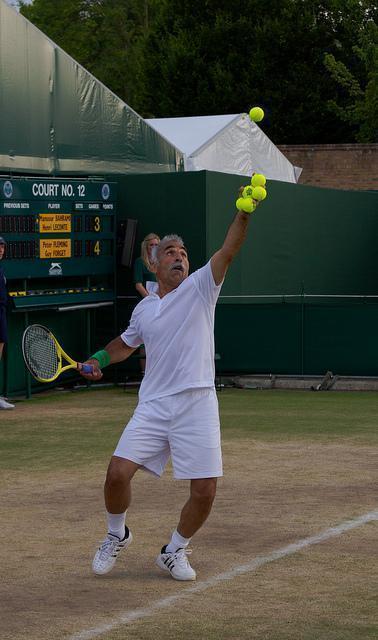Why is he holding several tennis balls?
Pick the correct solution from the four options below to address the question.
Options: Bombard opponent, standard gameplay, practicing serve, prevent theft. Practicing serve. 